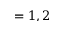<formula> <loc_0><loc_0><loc_500><loc_500>= 1 , 2</formula> 